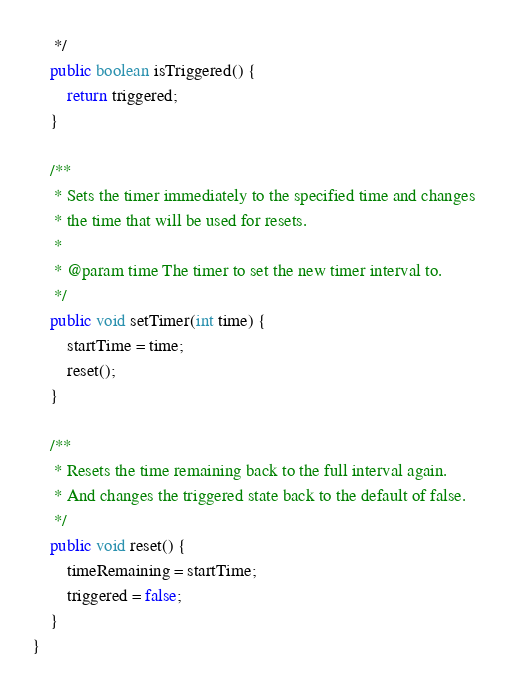<code> <loc_0><loc_0><loc_500><loc_500><_Java_>     */
    public boolean isTriggered() {
        return triggered;
    }

    /**
     * Sets the timer immediately to the specified time and changes
     * the time that will be used for resets.
     *
     * @param time The timer to set the new timer interval to.
     */
    public void setTimer(int time) {
        startTime = time;
        reset();
    }

    /**
     * Resets the time remaining back to the full interval again.
     * And changes the triggered state back to the default of false.
     */
    public void reset() {
        timeRemaining = startTime;
        triggered = false;
    }
}
</code> 